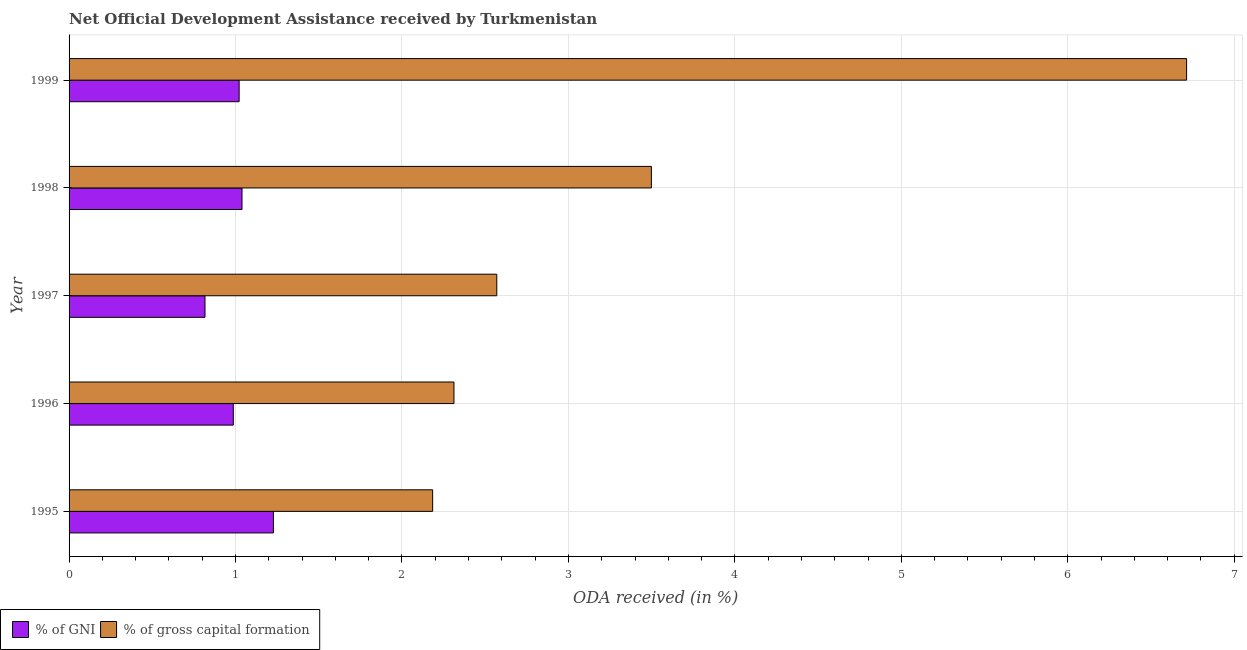How many bars are there on the 5th tick from the top?
Your response must be concise. 2. What is the label of the 5th group of bars from the top?
Provide a short and direct response. 1995. In how many cases, is the number of bars for a given year not equal to the number of legend labels?
Provide a short and direct response. 0. What is the oda received as percentage of gni in 1997?
Offer a terse response. 0.82. Across all years, what is the maximum oda received as percentage of gross capital formation?
Keep it short and to the point. 6.71. Across all years, what is the minimum oda received as percentage of gni?
Make the answer very short. 0.82. In which year was the oda received as percentage of gross capital formation maximum?
Keep it short and to the point. 1999. What is the total oda received as percentage of gni in the graph?
Make the answer very short. 5.09. What is the difference between the oda received as percentage of gross capital formation in 1996 and that in 1998?
Your answer should be compact. -1.19. What is the difference between the oda received as percentage of gross capital formation in 1998 and the oda received as percentage of gni in 1995?
Offer a terse response. 2.27. In the year 1997, what is the difference between the oda received as percentage of gross capital formation and oda received as percentage of gni?
Ensure brevity in your answer.  1.75. In how many years, is the oda received as percentage of gross capital formation greater than 3.8 %?
Your answer should be very brief. 1. What is the ratio of the oda received as percentage of gross capital formation in 1995 to that in 1999?
Your answer should be very brief. 0.33. Is the oda received as percentage of gni in 1996 less than that in 1997?
Provide a short and direct response. No. What is the difference between the highest and the second highest oda received as percentage of gross capital formation?
Make the answer very short. 3.21. What is the difference between the highest and the lowest oda received as percentage of gross capital formation?
Provide a succinct answer. 4.53. In how many years, is the oda received as percentage of gross capital formation greater than the average oda received as percentage of gross capital formation taken over all years?
Your answer should be very brief. 2. Is the sum of the oda received as percentage of gni in 1998 and 1999 greater than the maximum oda received as percentage of gross capital formation across all years?
Give a very brief answer. No. What does the 1st bar from the top in 1995 represents?
Provide a short and direct response. % of gross capital formation. What does the 1st bar from the bottom in 1999 represents?
Make the answer very short. % of GNI. How many years are there in the graph?
Provide a succinct answer. 5. Are the values on the major ticks of X-axis written in scientific E-notation?
Make the answer very short. No. Does the graph contain any zero values?
Give a very brief answer. No. Does the graph contain grids?
Provide a short and direct response. Yes. Where does the legend appear in the graph?
Offer a terse response. Bottom left. What is the title of the graph?
Provide a succinct answer. Net Official Development Assistance received by Turkmenistan. Does "Travel Items" appear as one of the legend labels in the graph?
Provide a short and direct response. No. What is the label or title of the X-axis?
Offer a very short reply. ODA received (in %). What is the ODA received (in %) of % of GNI in 1995?
Make the answer very short. 1.23. What is the ODA received (in %) in % of gross capital formation in 1995?
Your response must be concise. 2.18. What is the ODA received (in %) in % of GNI in 1996?
Provide a succinct answer. 0.99. What is the ODA received (in %) in % of gross capital formation in 1996?
Offer a very short reply. 2.31. What is the ODA received (in %) in % of GNI in 1997?
Ensure brevity in your answer.  0.82. What is the ODA received (in %) of % of gross capital formation in 1997?
Provide a succinct answer. 2.57. What is the ODA received (in %) in % of GNI in 1998?
Your answer should be compact. 1.04. What is the ODA received (in %) in % of gross capital formation in 1998?
Your answer should be compact. 3.5. What is the ODA received (in %) in % of GNI in 1999?
Your answer should be very brief. 1.02. What is the ODA received (in %) in % of gross capital formation in 1999?
Your answer should be compact. 6.71. Across all years, what is the maximum ODA received (in %) in % of GNI?
Your answer should be very brief. 1.23. Across all years, what is the maximum ODA received (in %) in % of gross capital formation?
Your response must be concise. 6.71. Across all years, what is the minimum ODA received (in %) in % of GNI?
Your answer should be compact. 0.82. Across all years, what is the minimum ODA received (in %) in % of gross capital formation?
Provide a short and direct response. 2.18. What is the total ODA received (in %) of % of GNI in the graph?
Keep it short and to the point. 5.09. What is the total ODA received (in %) in % of gross capital formation in the graph?
Your response must be concise. 17.28. What is the difference between the ODA received (in %) in % of GNI in 1995 and that in 1996?
Offer a very short reply. 0.24. What is the difference between the ODA received (in %) of % of gross capital formation in 1995 and that in 1996?
Your response must be concise. -0.13. What is the difference between the ODA received (in %) of % of GNI in 1995 and that in 1997?
Provide a succinct answer. 0.41. What is the difference between the ODA received (in %) in % of gross capital formation in 1995 and that in 1997?
Make the answer very short. -0.39. What is the difference between the ODA received (in %) in % of GNI in 1995 and that in 1998?
Make the answer very short. 0.19. What is the difference between the ODA received (in %) in % of gross capital formation in 1995 and that in 1998?
Your answer should be compact. -1.31. What is the difference between the ODA received (in %) in % of GNI in 1995 and that in 1999?
Your answer should be very brief. 0.21. What is the difference between the ODA received (in %) in % of gross capital formation in 1995 and that in 1999?
Ensure brevity in your answer.  -4.53. What is the difference between the ODA received (in %) of % of GNI in 1996 and that in 1997?
Provide a short and direct response. 0.17. What is the difference between the ODA received (in %) in % of gross capital formation in 1996 and that in 1997?
Your response must be concise. -0.26. What is the difference between the ODA received (in %) in % of GNI in 1996 and that in 1998?
Provide a short and direct response. -0.05. What is the difference between the ODA received (in %) in % of gross capital formation in 1996 and that in 1998?
Make the answer very short. -1.19. What is the difference between the ODA received (in %) in % of GNI in 1996 and that in 1999?
Your answer should be very brief. -0.04. What is the difference between the ODA received (in %) in % of gross capital formation in 1996 and that in 1999?
Your response must be concise. -4.4. What is the difference between the ODA received (in %) in % of GNI in 1997 and that in 1998?
Provide a short and direct response. -0.22. What is the difference between the ODA received (in %) of % of gross capital formation in 1997 and that in 1998?
Keep it short and to the point. -0.93. What is the difference between the ODA received (in %) in % of GNI in 1997 and that in 1999?
Give a very brief answer. -0.21. What is the difference between the ODA received (in %) in % of gross capital formation in 1997 and that in 1999?
Offer a very short reply. -4.14. What is the difference between the ODA received (in %) in % of GNI in 1998 and that in 1999?
Your answer should be compact. 0.02. What is the difference between the ODA received (in %) of % of gross capital formation in 1998 and that in 1999?
Ensure brevity in your answer.  -3.22. What is the difference between the ODA received (in %) in % of GNI in 1995 and the ODA received (in %) in % of gross capital formation in 1996?
Provide a short and direct response. -1.08. What is the difference between the ODA received (in %) in % of GNI in 1995 and the ODA received (in %) in % of gross capital formation in 1997?
Offer a terse response. -1.34. What is the difference between the ODA received (in %) of % of GNI in 1995 and the ODA received (in %) of % of gross capital formation in 1998?
Your answer should be compact. -2.27. What is the difference between the ODA received (in %) in % of GNI in 1995 and the ODA received (in %) in % of gross capital formation in 1999?
Give a very brief answer. -5.49. What is the difference between the ODA received (in %) in % of GNI in 1996 and the ODA received (in %) in % of gross capital formation in 1997?
Make the answer very short. -1.58. What is the difference between the ODA received (in %) of % of GNI in 1996 and the ODA received (in %) of % of gross capital formation in 1998?
Provide a short and direct response. -2.51. What is the difference between the ODA received (in %) in % of GNI in 1996 and the ODA received (in %) in % of gross capital formation in 1999?
Ensure brevity in your answer.  -5.73. What is the difference between the ODA received (in %) of % of GNI in 1997 and the ODA received (in %) of % of gross capital formation in 1998?
Provide a succinct answer. -2.68. What is the difference between the ODA received (in %) in % of GNI in 1997 and the ODA received (in %) in % of gross capital formation in 1999?
Offer a very short reply. -5.9. What is the difference between the ODA received (in %) of % of GNI in 1998 and the ODA received (in %) of % of gross capital formation in 1999?
Provide a succinct answer. -5.67. What is the average ODA received (in %) of % of GNI per year?
Offer a very short reply. 1.02. What is the average ODA received (in %) of % of gross capital formation per year?
Your answer should be very brief. 3.46. In the year 1995, what is the difference between the ODA received (in %) of % of GNI and ODA received (in %) of % of gross capital formation?
Give a very brief answer. -0.96. In the year 1996, what is the difference between the ODA received (in %) in % of GNI and ODA received (in %) in % of gross capital formation?
Offer a very short reply. -1.33. In the year 1997, what is the difference between the ODA received (in %) of % of GNI and ODA received (in %) of % of gross capital formation?
Keep it short and to the point. -1.75. In the year 1998, what is the difference between the ODA received (in %) in % of GNI and ODA received (in %) in % of gross capital formation?
Your answer should be very brief. -2.46. In the year 1999, what is the difference between the ODA received (in %) of % of GNI and ODA received (in %) of % of gross capital formation?
Your answer should be compact. -5.69. What is the ratio of the ODA received (in %) of % of GNI in 1995 to that in 1996?
Ensure brevity in your answer.  1.24. What is the ratio of the ODA received (in %) in % of gross capital formation in 1995 to that in 1996?
Give a very brief answer. 0.94. What is the ratio of the ODA received (in %) of % of GNI in 1995 to that in 1997?
Keep it short and to the point. 1.5. What is the ratio of the ODA received (in %) of % of gross capital formation in 1995 to that in 1997?
Make the answer very short. 0.85. What is the ratio of the ODA received (in %) of % of GNI in 1995 to that in 1998?
Provide a short and direct response. 1.18. What is the ratio of the ODA received (in %) of % of gross capital formation in 1995 to that in 1998?
Offer a very short reply. 0.62. What is the ratio of the ODA received (in %) of % of GNI in 1995 to that in 1999?
Your answer should be compact. 1.2. What is the ratio of the ODA received (in %) of % of gross capital formation in 1995 to that in 1999?
Keep it short and to the point. 0.33. What is the ratio of the ODA received (in %) in % of GNI in 1996 to that in 1997?
Your answer should be very brief. 1.21. What is the ratio of the ODA received (in %) of % of gross capital formation in 1996 to that in 1997?
Keep it short and to the point. 0.9. What is the ratio of the ODA received (in %) in % of GNI in 1996 to that in 1998?
Give a very brief answer. 0.95. What is the ratio of the ODA received (in %) in % of gross capital formation in 1996 to that in 1998?
Ensure brevity in your answer.  0.66. What is the ratio of the ODA received (in %) of % of GNI in 1996 to that in 1999?
Your answer should be compact. 0.97. What is the ratio of the ODA received (in %) of % of gross capital formation in 1996 to that in 1999?
Your response must be concise. 0.34. What is the ratio of the ODA received (in %) of % of GNI in 1997 to that in 1998?
Provide a succinct answer. 0.79. What is the ratio of the ODA received (in %) in % of gross capital formation in 1997 to that in 1998?
Provide a short and direct response. 0.73. What is the ratio of the ODA received (in %) in % of GNI in 1997 to that in 1999?
Your answer should be compact. 0.8. What is the ratio of the ODA received (in %) of % of gross capital formation in 1997 to that in 1999?
Give a very brief answer. 0.38. What is the ratio of the ODA received (in %) of % of GNI in 1998 to that in 1999?
Your answer should be very brief. 1.02. What is the ratio of the ODA received (in %) of % of gross capital formation in 1998 to that in 1999?
Give a very brief answer. 0.52. What is the difference between the highest and the second highest ODA received (in %) of % of GNI?
Give a very brief answer. 0.19. What is the difference between the highest and the second highest ODA received (in %) in % of gross capital formation?
Offer a terse response. 3.22. What is the difference between the highest and the lowest ODA received (in %) of % of GNI?
Ensure brevity in your answer.  0.41. What is the difference between the highest and the lowest ODA received (in %) of % of gross capital formation?
Ensure brevity in your answer.  4.53. 